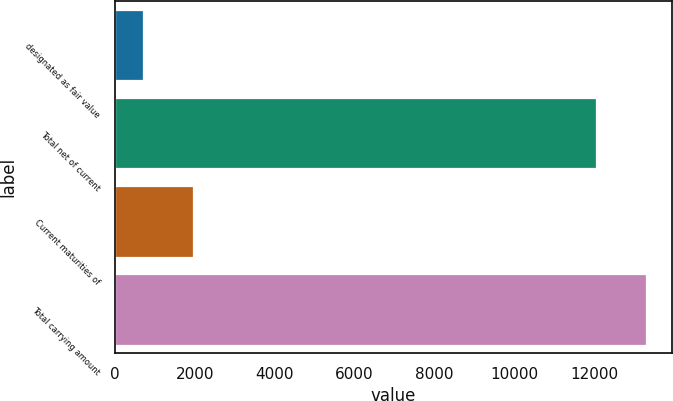<chart> <loc_0><loc_0><loc_500><loc_500><bar_chart><fcel>designated as fair value<fcel>Total net of current<fcel>Current maturities of<fcel>Total carrying amount<nl><fcel>719<fcel>12040<fcel>1953.8<fcel>13274.8<nl></chart> 